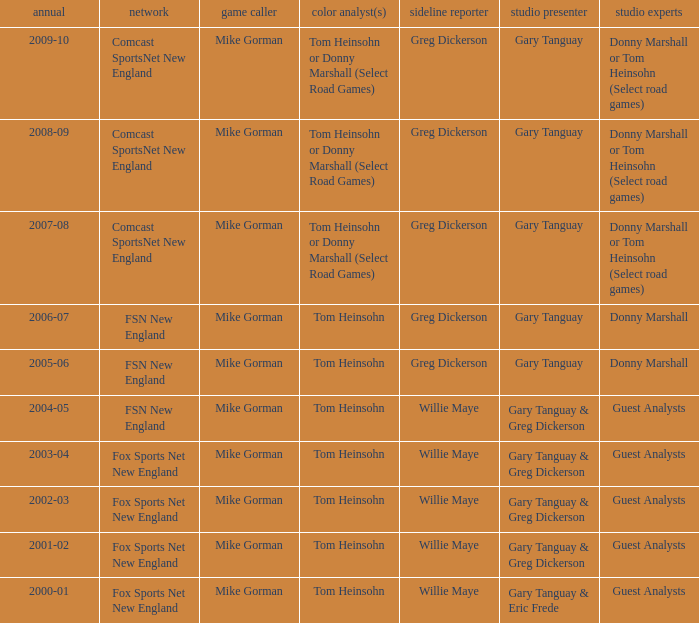Which Color commentator has a Channel of fsn new england, and a Year of 2004-05? Tom Heinsohn. 